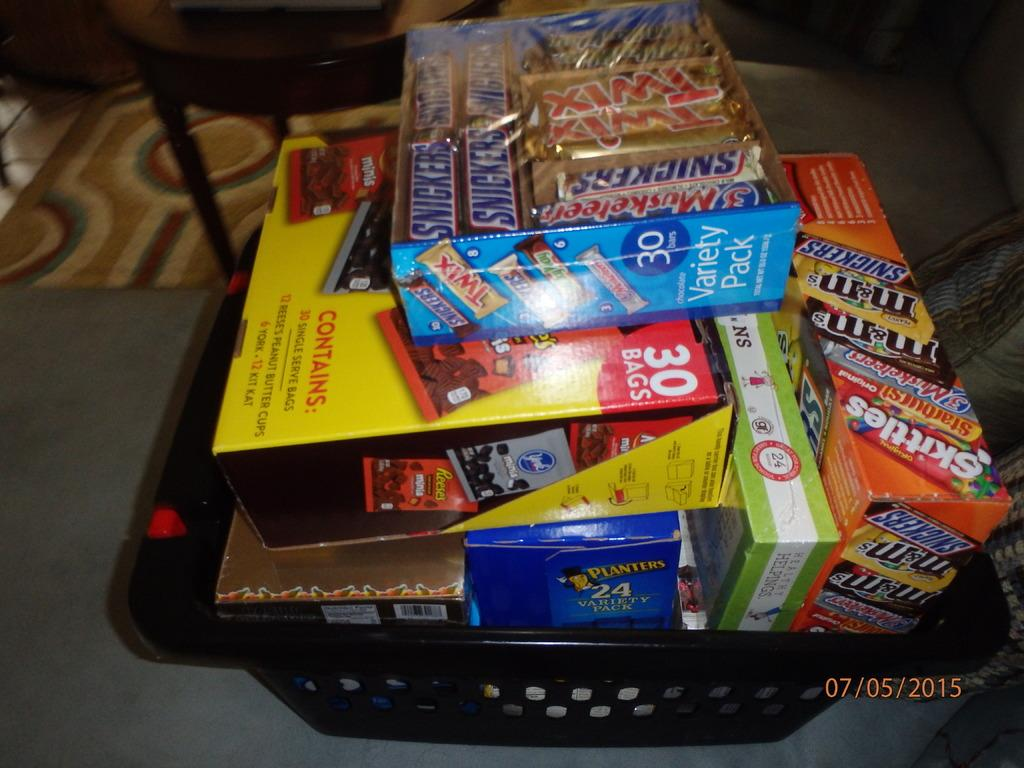<image>
Give a short and clear explanation of the subsequent image. A supermarket shopping basket is full of candy like Snickers bars and Skittles. 